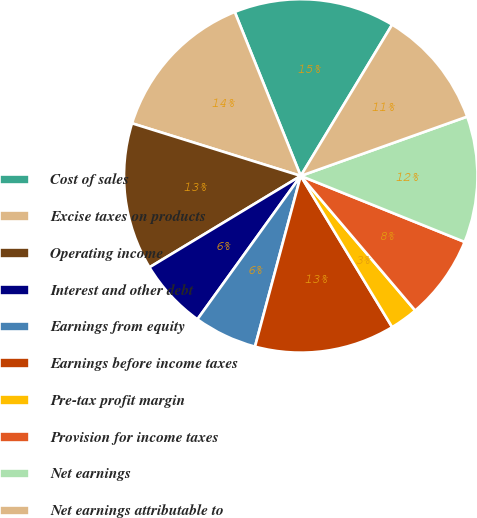<chart> <loc_0><loc_0><loc_500><loc_500><pie_chart><fcel>Cost of sales<fcel>Excise taxes on products<fcel>Operating income<fcel>Interest and other debt<fcel>Earnings from equity<fcel>Earnings before income taxes<fcel>Pre-tax profit margin<fcel>Provision for income taxes<fcel>Net earnings<fcel>Net earnings attributable to<nl><fcel>14.74%<fcel>14.1%<fcel>13.46%<fcel>6.41%<fcel>5.77%<fcel>12.82%<fcel>2.56%<fcel>7.69%<fcel>11.54%<fcel>10.9%<nl></chart> 